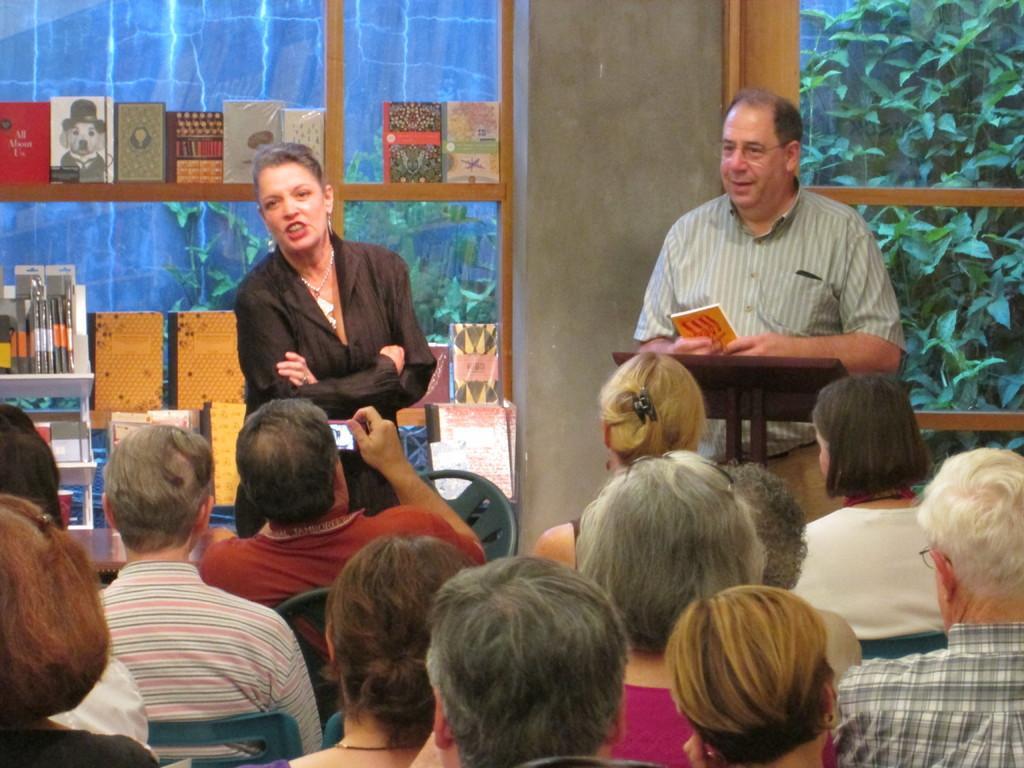How would you summarize this image in a sentence or two? In this image we can see a man and a woman standing. In that the man is standing beside a speaker stand holding a book. On the bottom of the image we can see a group of people sitting on the chairs. In that a person is holding a device. On the backside we can see some books placed in the shelves, a window, wall and some plants. 